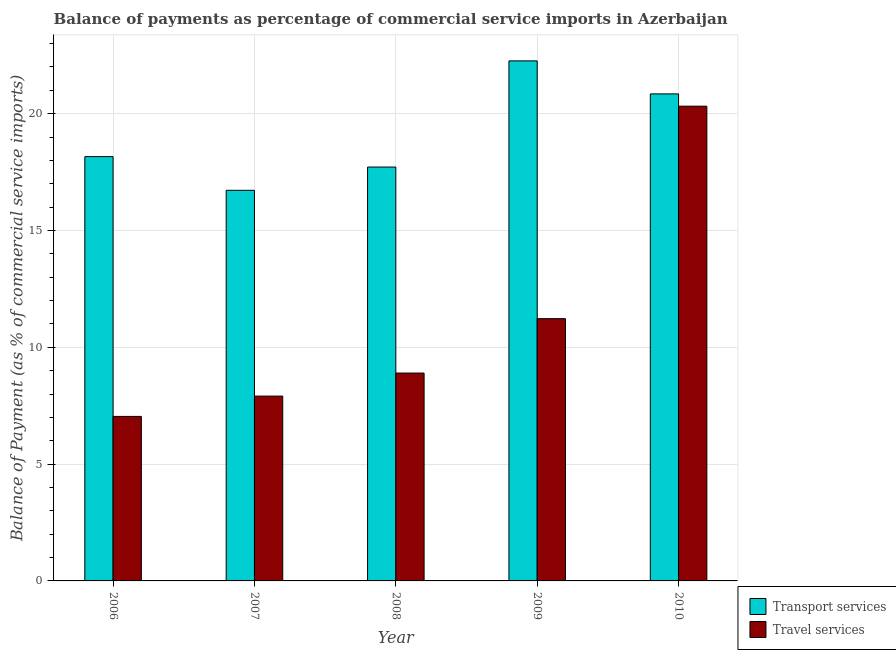Are the number of bars on each tick of the X-axis equal?
Provide a succinct answer. Yes. What is the balance of payments of transport services in 2008?
Offer a very short reply. 17.72. Across all years, what is the maximum balance of payments of travel services?
Offer a very short reply. 20.32. Across all years, what is the minimum balance of payments of transport services?
Provide a short and direct response. 16.72. In which year was the balance of payments of transport services minimum?
Keep it short and to the point. 2007. What is the total balance of payments of travel services in the graph?
Ensure brevity in your answer.  55.4. What is the difference between the balance of payments of transport services in 2008 and that in 2010?
Your answer should be compact. -3.13. What is the difference between the balance of payments of travel services in 2006 and the balance of payments of transport services in 2009?
Your answer should be compact. -4.18. What is the average balance of payments of transport services per year?
Provide a succinct answer. 19.14. In the year 2007, what is the difference between the balance of payments of transport services and balance of payments of travel services?
Keep it short and to the point. 0. What is the ratio of the balance of payments of travel services in 2007 to that in 2010?
Your response must be concise. 0.39. Is the balance of payments of transport services in 2007 less than that in 2008?
Give a very brief answer. Yes. Is the difference between the balance of payments of transport services in 2006 and 2007 greater than the difference between the balance of payments of travel services in 2006 and 2007?
Keep it short and to the point. No. What is the difference between the highest and the second highest balance of payments of transport services?
Provide a short and direct response. 1.41. What is the difference between the highest and the lowest balance of payments of travel services?
Offer a very short reply. 13.28. What does the 1st bar from the left in 2009 represents?
Your answer should be very brief. Transport services. What does the 2nd bar from the right in 2010 represents?
Provide a short and direct response. Transport services. How many years are there in the graph?
Provide a short and direct response. 5. What is the difference between two consecutive major ticks on the Y-axis?
Your response must be concise. 5. Does the graph contain any zero values?
Provide a succinct answer. No. Does the graph contain grids?
Keep it short and to the point. Yes. How many legend labels are there?
Offer a very short reply. 2. How are the legend labels stacked?
Offer a terse response. Vertical. What is the title of the graph?
Keep it short and to the point. Balance of payments as percentage of commercial service imports in Azerbaijan. What is the label or title of the Y-axis?
Offer a terse response. Balance of Payment (as % of commercial service imports). What is the Balance of Payment (as % of commercial service imports) of Transport services in 2006?
Give a very brief answer. 18.16. What is the Balance of Payment (as % of commercial service imports) of Travel services in 2006?
Provide a short and direct response. 7.04. What is the Balance of Payment (as % of commercial service imports) in Transport services in 2007?
Your response must be concise. 16.72. What is the Balance of Payment (as % of commercial service imports) of Travel services in 2007?
Your response must be concise. 7.91. What is the Balance of Payment (as % of commercial service imports) of Transport services in 2008?
Ensure brevity in your answer.  17.72. What is the Balance of Payment (as % of commercial service imports) in Travel services in 2008?
Your response must be concise. 8.9. What is the Balance of Payment (as % of commercial service imports) of Transport services in 2009?
Your response must be concise. 22.26. What is the Balance of Payment (as % of commercial service imports) in Travel services in 2009?
Ensure brevity in your answer.  11.23. What is the Balance of Payment (as % of commercial service imports) in Transport services in 2010?
Offer a very short reply. 20.85. What is the Balance of Payment (as % of commercial service imports) of Travel services in 2010?
Give a very brief answer. 20.32. Across all years, what is the maximum Balance of Payment (as % of commercial service imports) of Transport services?
Offer a terse response. 22.26. Across all years, what is the maximum Balance of Payment (as % of commercial service imports) of Travel services?
Provide a short and direct response. 20.32. Across all years, what is the minimum Balance of Payment (as % of commercial service imports) of Transport services?
Ensure brevity in your answer.  16.72. Across all years, what is the minimum Balance of Payment (as % of commercial service imports) of Travel services?
Your answer should be compact. 7.04. What is the total Balance of Payment (as % of commercial service imports) of Transport services in the graph?
Keep it short and to the point. 95.71. What is the total Balance of Payment (as % of commercial service imports) in Travel services in the graph?
Provide a short and direct response. 55.4. What is the difference between the Balance of Payment (as % of commercial service imports) of Transport services in 2006 and that in 2007?
Your answer should be compact. 1.44. What is the difference between the Balance of Payment (as % of commercial service imports) in Travel services in 2006 and that in 2007?
Ensure brevity in your answer.  -0.87. What is the difference between the Balance of Payment (as % of commercial service imports) in Transport services in 2006 and that in 2008?
Offer a terse response. 0.45. What is the difference between the Balance of Payment (as % of commercial service imports) in Travel services in 2006 and that in 2008?
Make the answer very short. -1.86. What is the difference between the Balance of Payment (as % of commercial service imports) of Transport services in 2006 and that in 2009?
Your answer should be compact. -4.1. What is the difference between the Balance of Payment (as % of commercial service imports) in Travel services in 2006 and that in 2009?
Keep it short and to the point. -4.18. What is the difference between the Balance of Payment (as % of commercial service imports) in Transport services in 2006 and that in 2010?
Your response must be concise. -2.69. What is the difference between the Balance of Payment (as % of commercial service imports) in Travel services in 2006 and that in 2010?
Offer a terse response. -13.28. What is the difference between the Balance of Payment (as % of commercial service imports) in Transport services in 2007 and that in 2008?
Provide a succinct answer. -1. What is the difference between the Balance of Payment (as % of commercial service imports) in Travel services in 2007 and that in 2008?
Give a very brief answer. -0.99. What is the difference between the Balance of Payment (as % of commercial service imports) of Transport services in 2007 and that in 2009?
Make the answer very short. -5.54. What is the difference between the Balance of Payment (as % of commercial service imports) in Travel services in 2007 and that in 2009?
Make the answer very short. -3.31. What is the difference between the Balance of Payment (as % of commercial service imports) of Transport services in 2007 and that in 2010?
Your answer should be very brief. -4.13. What is the difference between the Balance of Payment (as % of commercial service imports) in Travel services in 2007 and that in 2010?
Your response must be concise. -12.41. What is the difference between the Balance of Payment (as % of commercial service imports) of Transport services in 2008 and that in 2009?
Offer a very short reply. -4.55. What is the difference between the Balance of Payment (as % of commercial service imports) in Travel services in 2008 and that in 2009?
Ensure brevity in your answer.  -2.33. What is the difference between the Balance of Payment (as % of commercial service imports) in Transport services in 2008 and that in 2010?
Your answer should be very brief. -3.13. What is the difference between the Balance of Payment (as % of commercial service imports) in Travel services in 2008 and that in 2010?
Make the answer very short. -11.42. What is the difference between the Balance of Payment (as % of commercial service imports) in Transport services in 2009 and that in 2010?
Make the answer very short. 1.41. What is the difference between the Balance of Payment (as % of commercial service imports) in Travel services in 2009 and that in 2010?
Give a very brief answer. -9.1. What is the difference between the Balance of Payment (as % of commercial service imports) of Transport services in 2006 and the Balance of Payment (as % of commercial service imports) of Travel services in 2007?
Provide a succinct answer. 10.25. What is the difference between the Balance of Payment (as % of commercial service imports) of Transport services in 2006 and the Balance of Payment (as % of commercial service imports) of Travel services in 2008?
Your answer should be very brief. 9.26. What is the difference between the Balance of Payment (as % of commercial service imports) of Transport services in 2006 and the Balance of Payment (as % of commercial service imports) of Travel services in 2009?
Provide a succinct answer. 6.94. What is the difference between the Balance of Payment (as % of commercial service imports) in Transport services in 2006 and the Balance of Payment (as % of commercial service imports) in Travel services in 2010?
Offer a very short reply. -2.16. What is the difference between the Balance of Payment (as % of commercial service imports) of Transport services in 2007 and the Balance of Payment (as % of commercial service imports) of Travel services in 2008?
Your answer should be very brief. 7.82. What is the difference between the Balance of Payment (as % of commercial service imports) in Transport services in 2007 and the Balance of Payment (as % of commercial service imports) in Travel services in 2009?
Give a very brief answer. 5.49. What is the difference between the Balance of Payment (as % of commercial service imports) of Transport services in 2007 and the Balance of Payment (as % of commercial service imports) of Travel services in 2010?
Keep it short and to the point. -3.6. What is the difference between the Balance of Payment (as % of commercial service imports) in Transport services in 2008 and the Balance of Payment (as % of commercial service imports) in Travel services in 2009?
Your answer should be very brief. 6.49. What is the difference between the Balance of Payment (as % of commercial service imports) of Transport services in 2008 and the Balance of Payment (as % of commercial service imports) of Travel services in 2010?
Ensure brevity in your answer.  -2.61. What is the difference between the Balance of Payment (as % of commercial service imports) of Transport services in 2009 and the Balance of Payment (as % of commercial service imports) of Travel services in 2010?
Provide a short and direct response. 1.94. What is the average Balance of Payment (as % of commercial service imports) in Transport services per year?
Your response must be concise. 19.14. What is the average Balance of Payment (as % of commercial service imports) in Travel services per year?
Offer a terse response. 11.08. In the year 2006, what is the difference between the Balance of Payment (as % of commercial service imports) in Transport services and Balance of Payment (as % of commercial service imports) in Travel services?
Ensure brevity in your answer.  11.12. In the year 2007, what is the difference between the Balance of Payment (as % of commercial service imports) in Transport services and Balance of Payment (as % of commercial service imports) in Travel services?
Your answer should be very brief. 8.81. In the year 2008, what is the difference between the Balance of Payment (as % of commercial service imports) in Transport services and Balance of Payment (as % of commercial service imports) in Travel services?
Your answer should be very brief. 8.82. In the year 2009, what is the difference between the Balance of Payment (as % of commercial service imports) of Transport services and Balance of Payment (as % of commercial service imports) of Travel services?
Your answer should be compact. 11.04. In the year 2010, what is the difference between the Balance of Payment (as % of commercial service imports) of Transport services and Balance of Payment (as % of commercial service imports) of Travel services?
Offer a terse response. 0.53. What is the ratio of the Balance of Payment (as % of commercial service imports) in Transport services in 2006 to that in 2007?
Keep it short and to the point. 1.09. What is the ratio of the Balance of Payment (as % of commercial service imports) of Travel services in 2006 to that in 2007?
Your answer should be very brief. 0.89. What is the ratio of the Balance of Payment (as % of commercial service imports) of Transport services in 2006 to that in 2008?
Provide a short and direct response. 1.03. What is the ratio of the Balance of Payment (as % of commercial service imports) of Travel services in 2006 to that in 2008?
Your answer should be compact. 0.79. What is the ratio of the Balance of Payment (as % of commercial service imports) in Transport services in 2006 to that in 2009?
Ensure brevity in your answer.  0.82. What is the ratio of the Balance of Payment (as % of commercial service imports) in Travel services in 2006 to that in 2009?
Your response must be concise. 0.63. What is the ratio of the Balance of Payment (as % of commercial service imports) of Transport services in 2006 to that in 2010?
Offer a very short reply. 0.87. What is the ratio of the Balance of Payment (as % of commercial service imports) in Travel services in 2006 to that in 2010?
Offer a terse response. 0.35. What is the ratio of the Balance of Payment (as % of commercial service imports) of Transport services in 2007 to that in 2008?
Give a very brief answer. 0.94. What is the ratio of the Balance of Payment (as % of commercial service imports) in Travel services in 2007 to that in 2008?
Your answer should be very brief. 0.89. What is the ratio of the Balance of Payment (as % of commercial service imports) of Transport services in 2007 to that in 2009?
Provide a succinct answer. 0.75. What is the ratio of the Balance of Payment (as % of commercial service imports) in Travel services in 2007 to that in 2009?
Ensure brevity in your answer.  0.7. What is the ratio of the Balance of Payment (as % of commercial service imports) in Transport services in 2007 to that in 2010?
Your answer should be very brief. 0.8. What is the ratio of the Balance of Payment (as % of commercial service imports) of Travel services in 2007 to that in 2010?
Offer a very short reply. 0.39. What is the ratio of the Balance of Payment (as % of commercial service imports) of Transport services in 2008 to that in 2009?
Offer a terse response. 0.8. What is the ratio of the Balance of Payment (as % of commercial service imports) in Travel services in 2008 to that in 2009?
Your answer should be compact. 0.79. What is the ratio of the Balance of Payment (as % of commercial service imports) of Transport services in 2008 to that in 2010?
Your response must be concise. 0.85. What is the ratio of the Balance of Payment (as % of commercial service imports) of Travel services in 2008 to that in 2010?
Provide a succinct answer. 0.44. What is the ratio of the Balance of Payment (as % of commercial service imports) of Transport services in 2009 to that in 2010?
Your answer should be very brief. 1.07. What is the ratio of the Balance of Payment (as % of commercial service imports) in Travel services in 2009 to that in 2010?
Keep it short and to the point. 0.55. What is the difference between the highest and the second highest Balance of Payment (as % of commercial service imports) in Transport services?
Your answer should be compact. 1.41. What is the difference between the highest and the second highest Balance of Payment (as % of commercial service imports) in Travel services?
Your answer should be very brief. 9.1. What is the difference between the highest and the lowest Balance of Payment (as % of commercial service imports) in Transport services?
Ensure brevity in your answer.  5.54. What is the difference between the highest and the lowest Balance of Payment (as % of commercial service imports) of Travel services?
Ensure brevity in your answer.  13.28. 